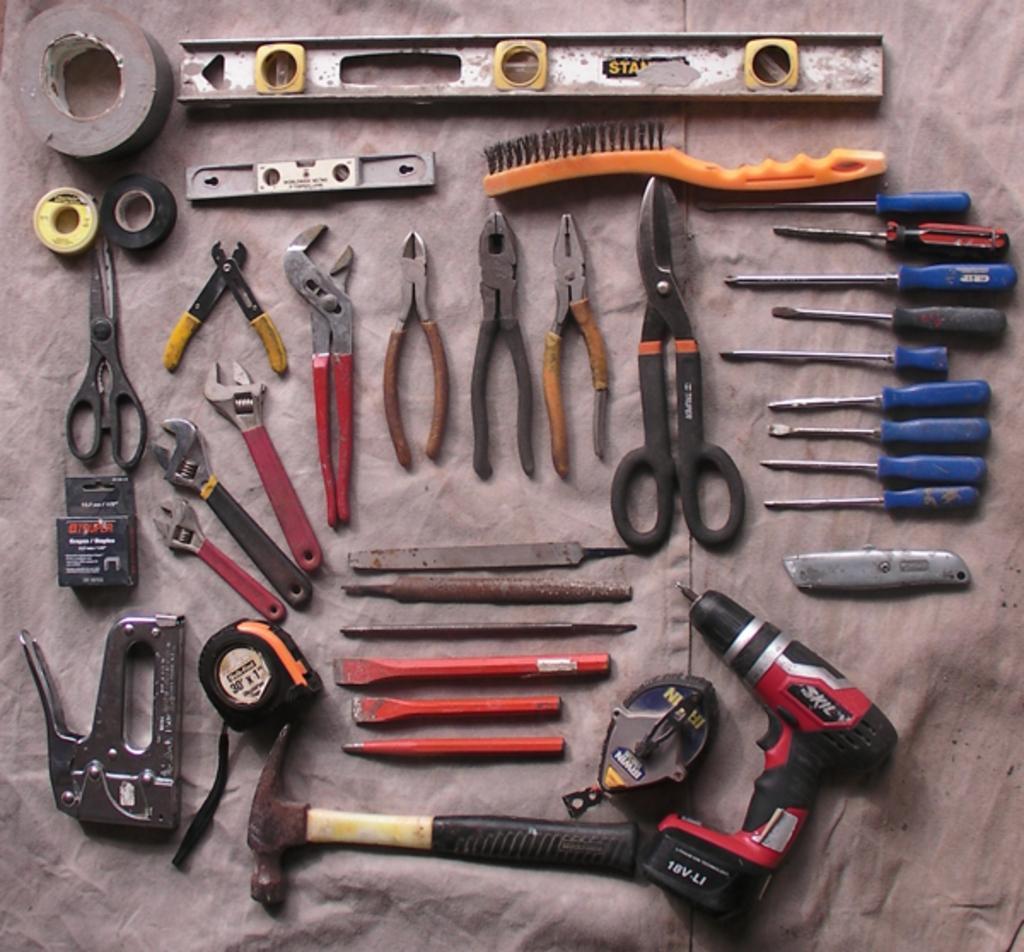Please provide a concise description of this image. In this image there are tools. 